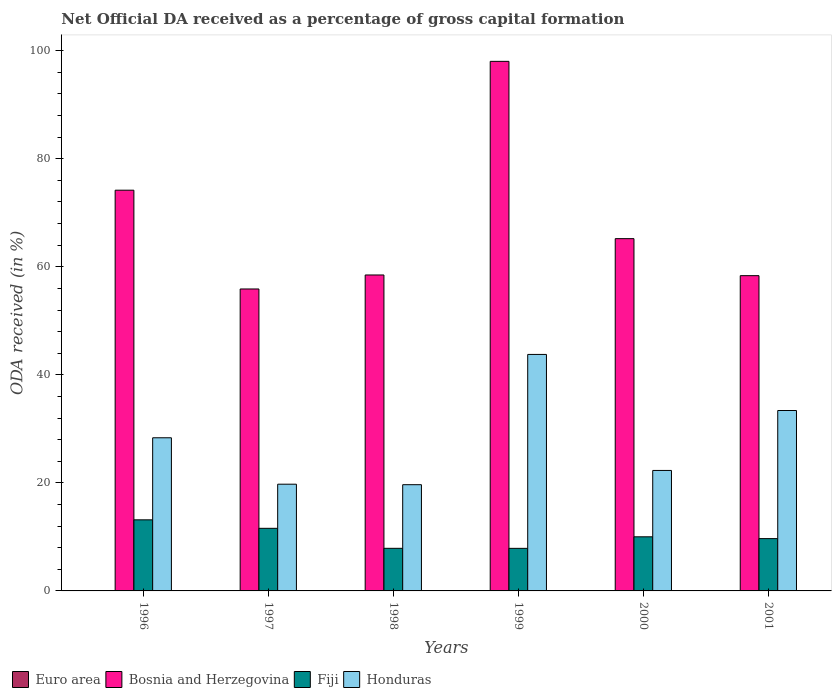How many groups of bars are there?
Keep it short and to the point. 6. How many bars are there on the 3rd tick from the left?
Your response must be concise. 4. How many bars are there on the 3rd tick from the right?
Give a very brief answer. 4. What is the label of the 6th group of bars from the left?
Provide a short and direct response. 2001. What is the net ODA received in Bosnia and Herzegovina in 2001?
Your response must be concise. 58.36. Across all years, what is the maximum net ODA received in Bosnia and Herzegovina?
Keep it short and to the point. 98.04. Across all years, what is the minimum net ODA received in Fiji?
Your answer should be very brief. 7.88. What is the total net ODA received in Bosnia and Herzegovina in the graph?
Offer a terse response. 410.18. What is the difference between the net ODA received in Euro area in 1998 and that in 1999?
Your answer should be compact. 0. What is the difference between the net ODA received in Fiji in 2000 and the net ODA received in Bosnia and Herzegovina in 1997?
Make the answer very short. -45.88. What is the average net ODA received in Euro area per year?
Ensure brevity in your answer.  0.01. In the year 1996, what is the difference between the net ODA received in Fiji and net ODA received in Euro area?
Your answer should be very brief. 13.15. In how many years, is the net ODA received in Bosnia and Herzegovina greater than 16 %?
Offer a terse response. 6. What is the ratio of the net ODA received in Fiji in 1999 to that in 2000?
Make the answer very short. 0.79. Is the net ODA received in Fiji in 1996 less than that in 1998?
Your response must be concise. No. What is the difference between the highest and the second highest net ODA received in Euro area?
Offer a terse response. 0. What is the difference between the highest and the lowest net ODA received in Honduras?
Give a very brief answer. 24.12. Is the sum of the net ODA received in Fiji in 1999 and 2001 greater than the maximum net ODA received in Bosnia and Herzegovina across all years?
Offer a terse response. No. Is it the case that in every year, the sum of the net ODA received in Bosnia and Herzegovina and net ODA received in Fiji is greater than the sum of net ODA received in Honduras and net ODA received in Euro area?
Your answer should be very brief. Yes. What does the 2nd bar from the left in 1997 represents?
Your answer should be compact. Bosnia and Herzegovina. What does the 3rd bar from the right in 1997 represents?
Offer a terse response. Bosnia and Herzegovina. Are all the bars in the graph horizontal?
Your answer should be very brief. No. How many years are there in the graph?
Provide a short and direct response. 6. Are the values on the major ticks of Y-axis written in scientific E-notation?
Provide a succinct answer. No. Does the graph contain grids?
Provide a short and direct response. No. How many legend labels are there?
Your answer should be very brief. 4. What is the title of the graph?
Provide a short and direct response. Net Official DA received as a percentage of gross capital formation. Does "Austria" appear as one of the legend labels in the graph?
Provide a succinct answer. No. What is the label or title of the X-axis?
Make the answer very short. Years. What is the label or title of the Y-axis?
Your answer should be compact. ODA received (in %). What is the ODA received (in %) in Euro area in 1996?
Your answer should be very brief. 0.01. What is the ODA received (in %) in Bosnia and Herzegovina in 1996?
Ensure brevity in your answer.  74.18. What is the ODA received (in %) of Fiji in 1996?
Provide a succinct answer. 13.16. What is the ODA received (in %) of Honduras in 1996?
Provide a succinct answer. 28.35. What is the ODA received (in %) of Euro area in 1997?
Offer a terse response. 0.01. What is the ODA received (in %) in Bosnia and Herzegovina in 1997?
Provide a succinct answer. 55.9. What is the ODA received (in %) in Fiji in 1997?
Offer a very short reply. 11.59. What is the ODA received (in %) in Honduras in 1997?
Offer a terse response. 19.76. What is the ODA received (in %) in Euro area in 1998?
Offer a terse response. 0. What is the ODA received (in %) of Bosnia and Herzegovina in 1998?
Ensure brevity in your answer.  58.49. What is the ODA received (in %) of Fiji in 1998?
Your answer should be very brief. 7.89. What is the ODA received (in %) of Honduras in 1998?
Offer a terse response. 19.66. What is the ODA received (in %) of Euro area in 1999?
Provide a short and direct response. 0. What is the ODA received (in %) in Bosnia and Herzegovina in 1999?
Keep it short and to the point. 98.04. What is the ODA received (in %) of Fiji in 1999?
Your answer should be compact. 7.88. What is the ODA received (in %) of Honduras in 1999?
Provide a succinct answer. 43.78. What is the ODA received (in %) of Euro area in 2000?
Keep it short and to the point. 0.01. What is the ODA received (in %) in Bosnia and Herzegovina in 2000?
Offer a very short reply. 65.21. What is the ODA received (in %) in Fiji in 2000?
Offer a very short reply. 10.02. What is the ODA received (in %) in Honduras in 2000?
Your answer should be very brief. 22.3. What is the ODA received (in %) of Euro area in 2001?
Offer a very short reply. 0.01. What is the ODA received (in %) of Bosnia and Herzegovina in 2001?
Your answer should be very brief. 58.36. What is the ODA received (in %) of Fiji in 2001?
Offer a very short reply. 9.68. What is the ODA received (in %) in Honduras in 2001?
Make the answer very short. 33.4. Across all years, what is the maximum ODA received (in %) in Euro area?
Offer a terse response. 0.01. Across all years, what is the maximum ODA received (in %) of Bosnia and Herzegovina?
Offer a terse response. 98.04. Across all years, what is the maximum ODA received (in %) of Fiji?
Ensure brevity in your answer.  13.16. Across all years, what is the maximum ODA received (in %) of Honduras?
Ensure brevity in your answer.  43.78. Across all years, what is the minimum ODA received (in %) in Euro area?
Give a very brief answer. 0. Across all years, what is the minimum ODA received (in %) in Bosnia and Herzegovina?
Your answer should be compact. 55.9. Across all years, what is the minimum ODA received (in %) in Fiji?
Offer a very short reply. 7.88. Across all years, what is the minimum ODA received (in %) in Honduras?
Provide a short and direct response. 19.66. What is the total ODA received (in %) in Euro area in the graph?
Your response must be concise. 0.04. What is the total ODA received (in %) of Bosnia and Herzegovina in the graph?
Ensure brevity in your answer.  410.18. What is the total ODA received (in %) in Fiji in the graph?
Offer a very short reply. 60.21. What is the total ODA received (in %) of Honduras in the graph?
Keep it short and to the point. 167.26. What is the difference between the ODA received (in %) of Euro area in 1996 and that in 1997?
Ensure brevity in your answer.  0. What is the difference between the ODA received (in %) in Bosnia and Herzegovina in 1996 and that in 1997?
Keep it short and to the point. 18.29. What is the difference between the ODA received (in %) of Fiji in 1996 and that in 1997?
Provide a short and direct response. 1.57. What is the difference between the ODA received (in %) of Honduras in 1996 and that in 1997?
Your response must be concise. 8.6. What is the difference between the ODA received (in %) in Euro area in 1996 and that in 1998?
Make the answer very short. 0.01. What is the difference between the ODA received (in %) of Bosnia and Herzegovina in 1996 and that in 1998?
Your answer should be compact. 15.7. What is the difference between the ODA received (in %) in Fiji in 1996 and that in 1998?
Make the answer very short. 5.27. What is the difference between the ODA received (in %) in Honduras in 1996 and that in 1998?
Make the answer very short. 8.69. What is the difference between the ODA received (in %) in Euro area in 1996 and that in 1999?
Your answer should be compact. 0.01. What is the difference between the ODA received (in %) of Bosnia and Herzegovina in 1996 and that in 1999?
Keep it short and to the point. -23.85. What is the difference between the ODA received (in %) in Fiji in 1996 and that in 1999?
Your answer should be very brief. 5.28. What is the difference between the ODA received (in %) in Honduras in 1996 and that in 1999?
Your answer should be compact. -15.43. What is the difference between the ODA received (in %) in Euro area in 1996 and that in 2000?
Keep it short and to the point. 0.01. What is the difference between the ODA received (in %) of Bosnia and Herzegovina in 1996 and that in 2000?
Your answer should be compact. 8.97. What is the difference between the ODA received (in %) of Fiji in 1996 and that in 2000?
Offer a very short reply. 3.14. What is the difference between the ODA received (in %) of Honduras in 1996 and that in 2000?
Ensure brevity in your answer.  6.05. What is the difference between the ODA received (in %) of Euro area in 1996 and that in 2001?
Make the answer very short. 0. What is the difference between the ODA received (in %) of Bosnia and Herzegovina in 1996 and that in 2001?
Your answer should be very brief. 15.82. What is the difference between the ODA received (in %) of Fiji in 1996 and that in 2001?
Offer a very short reply. 3.47. What is the difference between the ODA received (in %) of Honduras in 1996 and that in 2001?
Keep it short and to the point. -5.05. What is the difference between the ODA received (in %) of Euro area in 1997 and that in 1998?
Keep it short and to the point. 0. What is the difference between the ODA received (in %) of Bosnia and Herzegovina in 1997 and that in 1998?
Your answer should be very brief. -2.59. What is the difference between the ODA received (in %) in Fiji in 1997 and that in 1998?
Provide a succinct answer. 3.7. What is the difference between the ODA received (in %) in Honduras in 1997 and that in 1998?
Ensure brevity in your answer.  0.09. What is the difference between the ODA received (in %) of Euro area in 1997 and that in 1999?
Make the answer very short. 0. What is the difference between the ODA received (in %) in Bosnia and Herzegovina in 1997 and that in 1999?
Your answer should be compact. -42.14. What is the difference between the ODA received (in %) in Fiji in 1997 and that in 1999?
Provide a succinct answer. 3.71. What is the difference between the ODA received (in %) of Honduras in 1997 and that in 1999?
Ensure brevity in your answer.  -24.02. What is the difference between the ODA received (in %) in Euro area in 1997 and that in 2000?
Offer a terse response. 0. What is the difference between the ODA received (in %) in Bosnia and Herzegovina in 1997 and that in 2000?
Provide a short and direct response. -9.32. What is the difference between the ODA received (in %) in Fiji in 1997 and that in 2000?
Keep it short and to the point. 1.57. What is the difference between the ODA received (in %) in Honduras in 1997 and that in 2000?
Your response must be concise. -2.55. What is the difference between the ODA received (in %) in Euro area in 1997 and that in 2001?
Your answer should be very brief. -0. What is the difference between the ODA received (in %) in Bosnia and Herzegovina in 1997 and that in 2001?
Your response must be concise. -2.46. What is the difference between the ODA received (in %) in Fiji in 1997 and that in 2001?
Provide a short and direct response. 1.91. What is the difference between the ODA received (in %) in Honduras in 1997 and that in 2001?
Your response must be concise. -13.64. What is the difference between the ODA received (in %) in Euro area in 1998 and that in 1999?
Ensure brevity in your answer.  0. What is the difference between the ODA received (in %) of Bosnia and Herzegovina in 1998 and that in 1999?
Give a very brief answer. -39.55. What is the difference between the ODA received (in %) in Fiji in 1998 and that in 1999?
Keep it short and to the point. 0.01. What is the difference between the ODA received (in %) of Honduras in 1998 and that in 1999?
Provide a succinct answer. -24.12. What is the difference between the ODA received (in %) of Euro area in 1998 and that in 2000?
Offer a very short reply. -0. What is the difference between the ODA received (in %) of Bosnia and Herzegovina in 1998 and that in 2000?
Provide a succinct answer. -6.73. What is the difference between the ODA received (in %) of Fiji in 1998 and that in 2000?
Give a very brief answer. -2.13. What is the difference between the ODA received (in %) in Honduras in 1998 and that in 2000?
Offer a very short reply. -2.64. What is the difference between the ODA received (in %) of Euro area in 1998 and that in 2001?
Offer a terse response. -0. What is the difference between the ODA received (in %) of Bosnia and Herzegovina in 1998 and that in 2001?
Ensure brevity in your answer.  0.13. What is the difference between the ODA received (in %) of Fiji in 1998 and that in 2001?
Provide a succinct answer. -1.8. What is the difference between the ODA received (in %) of Honduras in 1998 and that in 2001?
Provide a short and direct response. -13.73. What is the difference between the ODA received (in %) in Euro area in 1999 and that in 2000?
Offer a terse response. -0. What is the difference between the ODA received (in %) of Bosnia and Herzegovina in 1999 and that in 2000?
Make the answer very short. 32.82. What is the difference between the ODA received (in %) of Fiji in 1999 and that in 2000?
Your answer should be very brief. -2.14. What is the difference between the ODA received (in %) of Honduras in 1999 and that in 2000?
Offer a very short reply. 21.48. What is the difference between the ODA received (in %) in Euro area in 1999 and that in 2001?
Provide a short and direct response. -0.01. What is the difference between the ODA received (in %) in Bosnia and Herzegovina in 1999 and that in 2001?
Your answer should be compact. 39.68. What is the difference between the ODA received (in %) of Fiji in 1999 and that in 2001?
Provide a succinct answer. -1.8. What is the difference between the ODA received (in %) in Honduras in 1999 and that in 2001?
Offer a terse response. 10.38. What is the difference between the ODA received (in %) in Euro area in 2000 and that in 2001?
Give a very brief answer. -0. What is the difference between the ODA received (in %) of Bosnia and Herzegovina in 2000 and that in 2001?
Your response must be concise. 6.85. What is the difference between the ODA received (in %) in Fiji in 2000 and that in 2001?
Your response must be concise. 0.33. What is the difference between the ODA received (in %) of Honduras in 2000 and that in 2001?
Keep it short and to the point. -11.1. What is the difference between the ODA received (in %) of Euro area in 1996 and the ODA received (in %) of Bosnia and Herzegovina in 1997?
Make the answer very short. -55.89. What is the difference between the ODA received (in %) in Euro area in 1996 and the ODA received (in %) in Fiji in 1997?
Ensure brevity in your answer.  -11.58. What is the difference between the ODA received (in %) in Euro area in 1996 and the ODA received (in %) in Honduras in 1997?
Give a very brief answer. -19.75. What is the difference between the ODA received (in %) in Bosnia and Herzegovina in 1996 and the ODA received (in %) in Fiji in 1997?
Make the answer very short. 62.59. What is the difference between the ODA received (in %) in Bosnia and Herzegovina in 1996 and the ODA received (in %) in Honduras in 1997?
Provide a succinct answer. 54.43. What is the difference between the ODA received (in %) in Fiji in 1996 and the ODA received (in %) in Honduras in 1997?
Your response must be concise. -6.6. What is the difference between the ODA received (in %) in Euro area in 1996 and the ODA received (in %) in Bosnia and Herzegovina in 1998?
Your answer should be very brief. -58.48. What is the difference between the ODA received (in %) in Euro area in 1996 and the ODA received (in %) in Fiji in 1998?
Ensure brevity in your answer.  -7.88. What is the difference between the ODA received (in %) in Euro area in 1996 and the ODA received (in %) in Honduras in 1998?
Provide a short and direct response. -19.65. What is the difference between the ODA received (in %) in Bosnia and Herzegovina in 1996 and the ODA received (in %) in Fiji in 1998?
Your response must be concise. 66.3. What is the difference between the ODA received (in %) of Bosnia and Herzegovina in 1996 and the ODA received (in %) of Honduras in 1998?
Give a very brief answer. 54.52. What is the difference between the ODA received (in %) in Fiji in 1996 and the ODA received (in %) in Honduras in 1998?
Give a very brief answer. -6.51. What is the difference between the ODA received (in %) in Euro area in 1996 and the ODA received (in %) in Bosnia and Herzegovina in 1999?
Provide a succinct answer. -98.03. What is the difference between the ODA received (in %) in Euro area in 1996 and the ODA received (in %) in Fiji in 1999?
Offer a terse response. -7.87. What is the difference between the ODA received (in %) of Euro area in 1996 and the ODA received (in %) of Honduras in 1999?
Offer a terse response. -43.77. What is the difference between the ODA received (in %) of Bosnia and Herzegovina in 1996 and the ODA received (in %) of Fiji in 1999?
Your answer should be compact. 66.3. What is the difference between the ODA received (in %) in Bosnia and Herzegovina in 1996 and the ODA received (in %) in Honduras in 1999?
Your answer should be compact. 30.4. What is the difference between the ODA received (in %) in Fiji in 1996 and the ODA received (in %) in Honduras in 1999?
Keep it short and to the point. -30.62. What is the difference between the ODA received (in %) of Euro area in 1996 and the ODA received (in %) of Bosnia and Herzegovina in 2000?
Offer a terse response. -65.2. What is the difference between the ODA received (in %) in Euro area in 1996 and the ODA received (in %) in Fiji in 2000?
Offer a very short reply. -10.01. What is the difference between the ODA received (in %) in Euro area in 1996 and the ODA received (in %) in Honduras in 2000?
Make the answer very short. -22.29. What is the difference between the ODA received (in %) of Bosnia and Herzegovina in 1996 and the ODA received (in %) of Fiji in 2000?
Offer a terse response. 64.17. What is the difference between the ODA received (in %) of Bosnia and Herzegovina in 1996 and the ODA received (in %) of Honduras in 2000?
Make the answer very short. 51.88. What is the difference between the ODA received (in %) of Fiji in 1996 and the ODA received (in %) of Honduras in 2000?
Your answer should be compact. -9.14. What is the difference between the ODA received (in %) in Euro area in 1996 and the ODA received (in %) in Bosnia and Herzegovina in 2001?
Offer a terse response. -58.35. What is the difference between the ODA received (in %) of Euro area in 1996 and the ODA received (in %) of Fiji in 2001?
Keep it short and to the point. -9.67. What is the difference between the ODA received (in %) in Euro area in 1996 and the ODA received (in %) in Honduras in 2001?
Offer a very short reply. -33.39. What is the difference between the ODA received (in %) of Bosnia and Herzegovina in 1996 and the ODA received (in %) of Fiji in 2001?
Offer a very short reply. 64.5. What is the difference between the ODA received (in %) of Bosnia and Herzegovina in 1996 and the ODA received (in %) of Honduras in 2001?
Make the answer very short. 40.79. What is the difference between the ODA received (in %) in Fiji in 1996 and the ODA received (in %) in Honduras in 2001?
Your answer should be compact. -20.24. What is the difference between the ODA received (in %) of Euro area in 1997 and the ODA received (in %) of Bosnia and Herzegovina in 1998?
Give a very brief answer. -58.48. What is the difference between the ODA received (in %) of Euro area in 1997 and the ODA received (in %) of Fiji in 1998?
Your response must be concise. -7.88. What is the difference between the ODA received (in %) of Euro area in 1997 and the ODA received (in %) of Honduras in 1998?
Provide a succinct answer. -19.66. What is the difference between the ODA received (in %) in Bosnia and Herzegovina in 1997 and the ODA received (in %) in Fiji in 1998?
Give a very brief answer. 48.01. What is the difference between the ODA received (in %) of Bosnia and Herzegovina in 1997 and the ODA received (in %) of Honduras in 1998?
Ensure brevity in your answer.  36.23. What is the difference between the ODA received (in %) in Fiji in 1997 and the ODA received (in %) in Honduras in 1998?
Provide a short and direct response. -8.08. What is the difference between the ODA received (in %) of Euro area in 1997 and the ODA received (in %) of Bosnia and Herzegovina in 1999?
Offer a terse response. -98.03. What is the difference between the ODA received (in %) of Euro area in 1997 and the ODA received (in %) of Fiji in 1999?
Keep it short and to the point. -7.87. What is the difference between the ODA received (in %) in Euro area in 1997 and the ODA received (in %) in Honduras in 1999?
Provide a short and direct response. -43.77. What is the difference between the ODA received (in %) of Bosnia and Herzegovina in 1997 and the ODA received (in %) of Fiji in 1999?
Provide a succinct answer. 48.02. What is the difference between the ODA received (in %) in Bosnia and Herzegovina in 1997 and the ODA received (in %) in Honduras in 1999?
Offer a terse response. 12.12. What is the difference between the ODA received (in %) of Fiji in 1997 and the ODA received (in %) of Honduras in 1999?
Keep it short and to the point. -32.19. What is the difference between the ODA received (in %) of Euro area in 1997 and the ODA received (in %) of Bosnia and Herzegovina in 2000?
Your answer should be compact. -65.21. What is the difference between the ODA received (in %) of Euro area in 1997 and the ODA received (in %) of Fiji in 2000?
Provide a succinct answer. -10.01. What is the difference between the ODA received (in %) of Euro area in 1997 and the ODA received (in %) of Honduras in 2000?
Make the answer very short. -22.29. What is the difference between the ODA received (in %) of Bosnia and Herzegovina in 1997 and the ODA received (in %) of Fiji in 2000?
Your response must be concise. 45.88. What is the difference between the ODA received (in %) of Bosnia and Herzegovina in 1997 and the ODA received (in %) of Honduras in 2000?
Keep it short and to the point. 33.6. What is the difference between the ODA received (in %) of Fiji in 1997 and the ODA received (in %) of Honduras in 2000?
Keep it short and to the point. -10.71. What is the difference between the ODA received (in %) of Euro area in 1997 and the ODA received (in %) of Bosnia and Herzegovina in 2001?
Keep it short and to the point. -58.35. What is the difference between the ODA received (in %) of Euro area in 1997 and the ODA received (in %) of Fiji in 2001?
Ensure brevity in your answer.  -9.68. What is the difference between the ODA received (in %) in Euro area in 1997 and the ODA received (in %) in Honduras in 2001?
Keep it short and to the point. -33.39. What is the difference between the ODA received (in %) of Bosnia and Herzegovina in 1997 and the ODA received (in %) of Fiji in 2001?
Offer a very short reply. 46.22. What is the difference between the ODA received (in %) of Bosnia and Herzegovina in 1997 and the ODA received (in %) of Honduras in 2001?
Your answer should be very brief. 22.5. What is the difference between the ODA received (in %) of Fiji in 1997 and the ODA received (in %) of Honduras in 2001?
Provide a succinct answer. -21.81. What is the difference between the ODA received (in %) in Euro area in 1998 and the ODA received (in %) in Bosnia and Herzegovina in 1999?
Your answer should be very brief. -98.03. What is the difference between the ODA received (in %) of Euro area in 1998 and the ODA received (in %) of Fiji in 1999?
Keep it short and to the point. -7.88. What is the difference between the ODA received (in %) in Euro area in 1998 and the ODA received (in %) in Honduras in 1999?
Make the answer very short. -43.78. What is the difference between the ODA received (in %) in Bosnia and Herzegovina in 1998 and the ODA received (in %) in Fiji in 1999?
Your answer should be very brief. 50.61. What is the difference between the ODA received (in %) of Bosnia and Herzegovina in 1998 and the ODA received (in %) of Honduras in 1999?
Your answer should be compact. 14.71. What is the difference between the ODA received (in %) of Fiji in 1998 and the ODA received (in %) of Honduras in 1999?
Keep it short and to the point. -35.9. What is the difference between the ODA received (in %) in Euro area in 1998 and the ODA received (in %) in Bosnia and Herzegovina in 2000?
Provide a succinct answer. -65.21. What is the difference between the ODA received (in %) in Euro area in 1998 and the ODA received (in %) in Fiji in 2000?
Your response must be concise. -10.01. What is the difference between the ODA received (in %) of Euro area in 1998 and the ODA received (in %) of Honduras in 2000?
Your response must be concise. -22.3. What is the difference between the ODA received (in %) in Bosnia and Herzegovina in 1998 and the ODA received (in %) in Fiji in 2000?
Your answer should be compact. 48.47. What is the difference between the ODA received (in %) of Bosnia and Herzegovina in 1998 and the ODA received (in %) of Honduras in 2000?
Offer a terse response. 36.19. What is the difference between the ODA received (in %) in Fiji in 1998 and the ODA received (in %) in Honduras in 2000?
Keep it short and to the point. -14.42. What is the difference between the ODA received (in %) in Euro area in 1998 and the ODA received (in %) in Bosnia and Herzegovina in 2001?
Provide a short and direct response. -58.36. What is the difference between the ODA received (in %) in Euro area in 1998 and the ODA received (in %) in Fiji in 2001?
Offer a very short reply. -9.68. What is the difference between the ODA received (in %) in Euro area in 1998 and the ODA received (in %) in Honduras in 2001?
Give a very brief answer. -33.39. What is the difference between the ODA received (in %) of Bosnia and Herzegovina in 1998 and the ODA received (in %) of Fiji in 2001?
Give a very brief answer. 48.81. What is the difference between the ODA received (in %) of Bosnia and Herzegovina in 1998 and the ODA received (in %) of Honduras in 2001?
Offer a very short reply. 25.09. What is the difference between the ODA received (in %) in Fiji in 1998 and the ODA received (in %) in Honduras in 2001?
Provide a succinct answer. -25.51. What is the difference between the ODA received (in %) in Euro area in 1999 and the ODA received (in %) in Bosnia and Herzegovina in 2000?
Offer a terse response. -65.21. What is the difference between the ODA received (in %) of Euro area in 1999 and the ODA received (in %) of Fiji in 2000?
Your response must be concise. -10.01. What is the difference between the ODA received (in %) of Euro area in 1999 and the ODA received (in %) of Honduras in 2000?
Your answer should be very brief. -22.3. What is the difference between the ODA received (in %) of Bosnia and Herzegovina in 1999 and the ODA received (in %) of Fiji in 2000?
Give a very brief answer. 88.02. What is the difference between the ODA received (in %) in Bosnia and Herzegovina in 1999 and the ODA received (in %) in Honduras in 2000?
Offer a terse response. 75.73. What is the difference between the ODA received (in %) of Fiji in 1999 and the ODA received (in %) of Honduras in 2000?
Keep it short and to the point. -14.42. What is the difference between the ODA received (in %) of Euro area in 1999 and the ODA received (in %) of Bosnia and Herzegovina in 2001?
Ensure brevity in your answer.  -58.36. What is the difference between the ODA received (in %) in Euro area in 1999 and the ODA received (in %) in Fiji in 2001?
Ensure brevity in your answer.  -9.68. What is the difference between the ODA received (in %) of Euro area in 1999 and the ODA received (in %) of Honduras in 2001?
Give a very brief answer. -33.4. What is the difference between the ODA received (in %) in Bosnia and Herzegovina in 1999 and the ODA received (in %) in Fiji in 2001?
Your answer should be compact. 88.35. What is the difference between the ODA received (in %) of Bosnia and Herzegovina in 1999 and the ODA received (in %) of Honduras in 2001?
Your answer should be very brief. 64.64. What is the difference between the ODA received (in %) in Fiji in 1999 and the ODA received (in %) in Honduras in 2001?
Your answer should be very brief. -25.52. What is the difference between the ODA received (in %) of Euro area in 2000 and the ODA received (in %) of Bosnia and Herzegovina in 2001?
Offer a very short reply. -58.36. What is the difference between the ODA received (in %) of Euro area in 2000 and the ODA received (in %) of Fiji in 2001?
Give a very brief answer. -9.68. What is the difference between the ODA received (in %) in Euro area in 2000 and the ODA received (in %) in Honduras in 2001?
Provide a succinct answer. -33.39. What is the difference between the ODA received (in %) in Bosnia and Herzegovina in 2000 and the ODA received (in %) in Fiji in 2001?
Make the answer very short. 55.53. What is the difference between the ODA received (in %) in Bosnia and Herzegovina in 2000 and the ODA received (in %) in Honduras in 2001?
Your response must be concise. 31.82. What is the difference between the ODA received (in %) of Fiji in 2000 and the ODA received (in %) of Honduras in 2001?
Offer a terse response. -23.38. What is the average ODA received (in %) in Euro area per year?
Your response must be concise. 0.01. What is the average ODA received (in %) in Bosnia and Herzegovina per year?
Offer a terse response. 68.36. What is the average ODA received (in %) of Fiji per year?
Offer a very short reply. 10.04. What is the average ODA received (in %) in Honduras per year?
Provide a succinct answer. 27.88. In the year 1996, what is the difference between the ODA received (in %) of Euro area and ODA received (in %) of Bosnia and Herzegovina?
Keep it short and to the point. -74.17. In the year 1996, what is the difference between the ODA received (in %) in Euro area and ODA received (in %) in Fiji?
Ensure brevity in your answer.  -13.15. In the year 1996, what is the difference between the ODA received (in %) of Euro area and ODA received (in %) of Honduras?
Your answer should be very brief. -28.34. In the year 1996, what is the difference between the ODA received (in %) of Bosnia and Herzegovina and ODA received (in %) of Fiji?
Provide a short and direct response. 61.03. In the year 1996, what is the difference between the ODA received (in %) of Bosnia and Herzegovina and ODA received (in %) of Honduras?
Your answer should be very brief. 45.83. In the year 1996, what is the difference between the ODA received (in %) in Fiji and ODA received (in %) in Honduras?
Provide a succinct answer. -15.19. In the year 1997, what is the difference between the ODA received (in %) of Euro area and ODA received (in %) of Bosnia and Herzegovina?
Ensure brevity in your answer.  -55.89. In the year 1997, what is the difference between the ODA received (in %) of Euro area and ODA received (in %) of Fiji?
Provide a succinct answer. -11.58. In the year 1997, what is the difference between the ODA received (in %) in Euro area and ODA received (in %) in Honduras?
Provide a short and direct response. -19.75. In the year 1997, what is the difference between the ODA received (in %) in Bosnia and Herzegovina and ODA received (in %) in Fiji?
Make the answer very short. 44.31. In the year 1997, what is the difference between the ODA received (in %) of Bosnia and Herzegovina and ODA received (in %) of Honduras?
Ensure brevity in your answer.  36.14. In the year 1997, what is the difference between the ODA received (in %) of Fiji and ODA received (in %) of Honduras?
Ensure brevity in your answer.  -8.17. In the year 1998, what is the difference between the ODA received (in %) in Euro area and ODA received (in %) in Bosnia and Herzegovina?
Ensure brevity in your answer.  -58.49. In the year 1998, what is the difference between the ODA received (in %) in Euro area and ODA received (in %) in Fiji?
Ensure brevity in your answer.  -7.88. In the year 1998, what is the difference between the ODA received (in %) in Euro area and ODA received (in %) in Honduras?
Keep it short and to the point. -19.66. In the year 1998, what is the difference between the ODA received (in %) of Bosnia and Herzegovina and ODA received (in %) of Fiji?
Make the answer very short. 50.6. In the year 1998, what is the difference between the ODA received (in %) of Bosnia and Herzegovina and ODA received (in %) of Honduras?
Keep it short and to the point. 38.82. In the year 1998, what is the difference between the ODA received (in %) in Fiji and ODA received (in %) in Honduras?
Make the answer very short. -11.78. In the year 1999, what is the difference between the ODA received (in %) in Euro area and ODA received (in %) in Bosnia and Herzegovina?
Ensure brevity in your answer.  -98.03. In the year 1999, what is the difference between the ODA received (in %) in Euro area and ODA received (in %) in Fiji?
Your response must be concise. -7.88. In the year 1999, what is the difference between the ODA received (in %) of Euro area and ODA received (in %) of Honduras?
Keep it short and to the point. -43.78. In the year 1999, what is the difference between the ODA received (in %) of Bosnia and Herzegovina and ODA received (in %) of Fiji?
Give a very brief answer. 90.16. In the year 1999, what is the difference between the ODA received (in %) in Bosnia and Herzegovina and ODA received (in %) in Honduras?
Ensure brevity in your answer.  54.25. In the year 1999, what is the difference between the ODA received (in %) of Fiji and ODA received (in %) of Honduras?
Your response must be concise. -35.9. In the year 2000, what is the difference between the ODA received (in %) in Euro area and ODA received (in %) in Bosnia and Herzegovina?
Ensure brevity in your answer.  -65.21. In the year 2000, what is the difference between the ODA received (in %) in Euro area and ODA received (in %) in Fiji?
Your answer should be compact. -10.01. In the year 2000, what is the difference between the ODA received (in %) of Euro area and ODA received (in %) of Honduras?
Provide a short and direct response. -22.3. In the year 2000, what is the difference between the ODA received (in %) in Bosnia and Herzegovina and ODA received (in %) in Fiji?
Your answer should be compact. 55.2. In the year 2000, what is the difference between the ODA received (in %) in Bosnia and Herzegovina and ODA received (in %) in Honduras?
Offer a terse response. 42.91. In the year 2000, what is the difference between the ODA received (in %) in Fiji and ODA received (in %) in Honduras?
Your answer should be very brief. -12.29. In the year 2001, what is the difference between the ODA received (in %) in Euro area and ODA received (in %) in Bosnia and Herzegovina?
Keep it short and to the point. -58.35. In the year 2001, what is the difference between the ODA received (in %) in Euro area and ODA received (in %) in Fiji?
Keep it short and to the point. -9.68. In the year 2001, what is the difference between the ODA received (in %) in Euro area and ODA received (in %) in Honduras?
Provide a succinct answer. -33.39. In the year 2001, what is the difference between the ODA received (in %) of Bosnia and Herzegovina and ODA received (in %) of Fiji?
Your answer should be compact. 48.68. In the year 2001, what is the difference between the ODA received (in %) of Bosnia and Herzegovina and ODA received (in %) of Honduras?
Provide a short and direct response. 24.96. In the year 2001, what is the difference between the ODA received (in %) in Fiji and ODA received (in %) in Honduras?
Your answer should be very brief. -23.71. What is the ratio of the ODA received (in %) in Euro area in 1996 to that in 1997?
Provide a short and direct response. 1.37. What is the ratio of the ODA received (in %) in Bosnia and Herzegovina in 1996 to that in 1997?
Your response must be concise. 1.33. What is the ratio of the ODA received (in %) in Fiji in 1996 to that in 1997?
Your answer should be compact. 1.14. What is the ratio of the ODA received (in %) of Honduras in 1996 to that in 1997?
Make the answer very short. 1.44. What is the ratio of the ODA received (in %) of Euro area in 1996 to that in 1998?
Provide a succinct answer. 2.81. What is the ratio of the ODA received (in %) of Bosnia and Herzegovina in 1996 to that in 1998?
Give a very brief answer. 1.27. What is the ratio of the ODA received (in %) of Fiji in 1996 to that in 1998?
Provide a succinct answer. 1.67. What is the ratio of the ODA received (in %) in Honduras in 1996 to that in 1998?
Provide a succinct answer. 1.44. What is the ratio of the ODA received (in %) in Euro area in 1996 to that in 1999?
Offer a very short reply. 3.13. What is the ratio of the ODA received (in %) of Bosnia and Herzegovina in 1996 to that in 1999?
Offer a terse response. 0.76. What is the ratio of the ODA received (in %) of Fiji in 1996 to that in 1999?
Offer a terse response. 1.67. What is the ratio of the ODA received (in %) in Honduras in 1996 to that in 1999?
Keep it short and to the point. 0.65. What is the ratio of the ODA received (in %) of Euro area in 1996 to that in 2000?
Your answer should be very brief. 2.01. What is the ratio of the ODA received (in %) in Bosnia and Herzegovina in 1996 to that in 2000?
Keep it short and to the point. 1.14. What is the ratio of the ODA received (in %) of Fiji in 1996 to that in 2000?
Your answer should be very brief. 1.31. What is the ratio of the ODA received (in %) in Honduras in 1996 to that in 2000?
Offer a terse response. 1.27. What is the ratio of the ODA received (in %) of Euro area in 1996 to that in 2001?
Your response must be concise. 1.28. What is the ratio of the ODA received (in %) in Bosnia and Herzegovina in 1996 to that in 2001?
Offer a terse response. 1.27. What is the ratio of the ODA received (in %) of Fiji in 1996 to that in 2001?
Your answer should be very brief. 1.36. What is the ratio of the ODA received (in %) of Honduras in 1996 to that in 2001?
Your response must be concise. 0.85. What is the ratio of the ODA received (in %) in Euro area in 1997 to that in 1998?
Ensure brevity in your answer.  2.05. What is the ratio of the ODA received (in %) in Bosnia and Herzegovina in 1997 to that in 1998?
Keep it short and to the point. 0.96. What is the ratio of the ODA received (in %) in Fiji in 1997 to that in 1998?
Keep it short and to the point. 1.47. What is the ratio of the ODA received (in %) in Euro area in 1997 to that in 1999?
Give a very brief answer. 2.29. What is the ratio of the ODA received (in %) in Bosnia and Herzegovina in 1997 to that in 1999?
Offer a terse response. 0.57. What is the ratio of the ODA received (in %) in Fiji in 1997 to that in 1999?
Give a very brief answer. 1.47. What is the ratio of the ODA received (in %) of Honduras in 1997 to that in 1999?
Give a very brief answer. 0.45. What is the ratio of the ODA received (in %) of Euro area in 1997 to that in 2000?
Give a very brief answer. 1.47. What is the ratio of the ODA received (in %) of Bosnia and Herzegovina in 1997 to that in 2000?
Provide a succinct answer. 0.86. What is the ratio of the ODA received (in %) of Fiji in 1997 to that in 2000?
Keep it short and to the point. 1.16. What is the ratio of the ODA received (in %) in Honduras in 1997 to that in 2000?
Provide a succinct answer. 0.89. What is the ratio of the ODA received (in %) of Euro area in 1997 to that in 2001?
Give a very brief answer. 0.93. What is the ratio of the ODA received (in %) of Bosnia and Herzegovina in 1997 to that in 2001?
Keep it short and to the point. 0.96. What is the ratio of the ODA received (in %) of Fiji in 1997 to that in 2001?
Your answer should be very brief. 1.2. What is the ratio of the ODA received (in %) of Honduras in 1997 to that in 2001?
Your answer should be compact. 0.59. What is the ratio of the ODA received (in %) of Euro area in 1998 to that in 1999?
Keep it short and to the point. 1.11. What is the ratio of the ODA received (in %) of Bosnia and Herzegovina in 1998 to that in 1999?
Give a very brief answer. 0.6. What is the ratio of the ODA received (in %) in Honduras in 1998 to that in 1999?
Ensure brevity in your answer.  0.45. What is the ratio of the ODA received (in %) in Euro area in 1998 to that in 2000?
Give a very brief answer. 0.71. What is the ratio of the ODA received (in %) in Bosnia and Herzegovina in 1998 to that in 2000?
Provide a succinct answer. 0.9. What is the ratio of the ODA received (in %) of Fiji in 1998 to that in 2000?
Your response must be concise. 0.79. What is the ratio of the ODA received (in %) in Honduras in 1998 to that in 2000?
Your answer should be very brief. 0.88. What is the ratio of the ODA received (in %) of Euro area in 1998 to that in 2001?
Keep it short and to the point. 0.45. What is the ratio of the ODA received (in %) in Fiji in 1998 to that in 2001?
Give a very brief answer. 0.81. What is the ratio of the ODA received (in %) of Honduras in 1998 to that in 2001?
Provide a succinct answer. 0.59. What is the ratio of the ODA received (in %) in Euro area in 1999 to that in 2000?
Ensure brevity in your answer.  0.64. What is the ratio of the ODA received (in %) in Bosnia and Herzegovina in 1999 to that in 2000?
Your response must be concise. 1.5. What is the ratio of the ODA received (in %) of Fiji in 1999 to that in 2000?
Keep it short and to the point. 0.79. What is the ratio of the ODA received (in %) in Honduras in 1999 to that in 2000?
Your response must be concise. 1.96. What is the ratio of the ODA received (in %) of Euro area in 1999 to that in 2001?
Your response must be concise. 0.41. What is the ratio of the ODA received (in %) in Bosnia and Herzegovina in 1999 to that in 2001?
Provide a short and direct response. 1.68. What is the ratio of the ODA received (in %) in Fiji in 1999 to that in 2001?
Offer a very short reply. 0.81. What is the ratio of the ODA received (in %) of Honduras in 1999 to that in 2001?
Give a very brief answer. 1.31. What is the ratio of the ODA received (in %) of Euro area in 2000 to that in 2001?
Make the answer very short. 0.64. What is the ratio of the ODA received (in %) of Bosnia and Herzegovina in 2000 to that in 2001?
Make the answer very short. 1.12. What is the ratio of the ODA received (in %) of Fiji in 2000 to that in 2001?
Your response must be concise. 1.03. What is the ratio of the ODA received (in %) of Honduras in 2000 to that in 2001?
Your answer should be compact. 0.67. What is the difference between the highest and the second highest ODA received (in %) in Euro area?
Your answer should be very brief. 0. What is the difference between the highest and the second highest ODA received (in %) in Bosnia and Herzegovina?
Your response must be concise. 23.85. What is the difference between the highest and the second highest ODA received (in %) in Fiji?
Make the answer very short. 1.57. What is the difference between the highest and the second highest ODA received (in %) in Honduras?
Your answer should be compact. 10.38. What is the difference between the highest and the lowest ODA received (in %) of Euro area?
Your answer should be very brief. 0.01. What is the difference between the highest and the lowest ODA received (in %) in Bosnia and Herzegovina?
Ensure brevity in your answer.  42.14. What is the difference between the highest and the lowest ODA received (in %) in Fiji?
Provide a short and direct response. 5.28. What is the difference between the highest and the lowest ODA received (in %) in Honduras?
Make the answer very short. 24.12. 